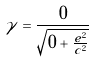<formula> <loc_0><loc_0><loc_500><loc_500>\gamma = \frac { 0 } { \sqrt { 0 + \frac { e ^ { 2 } } { c ^ { 2 } } } }</formula> 